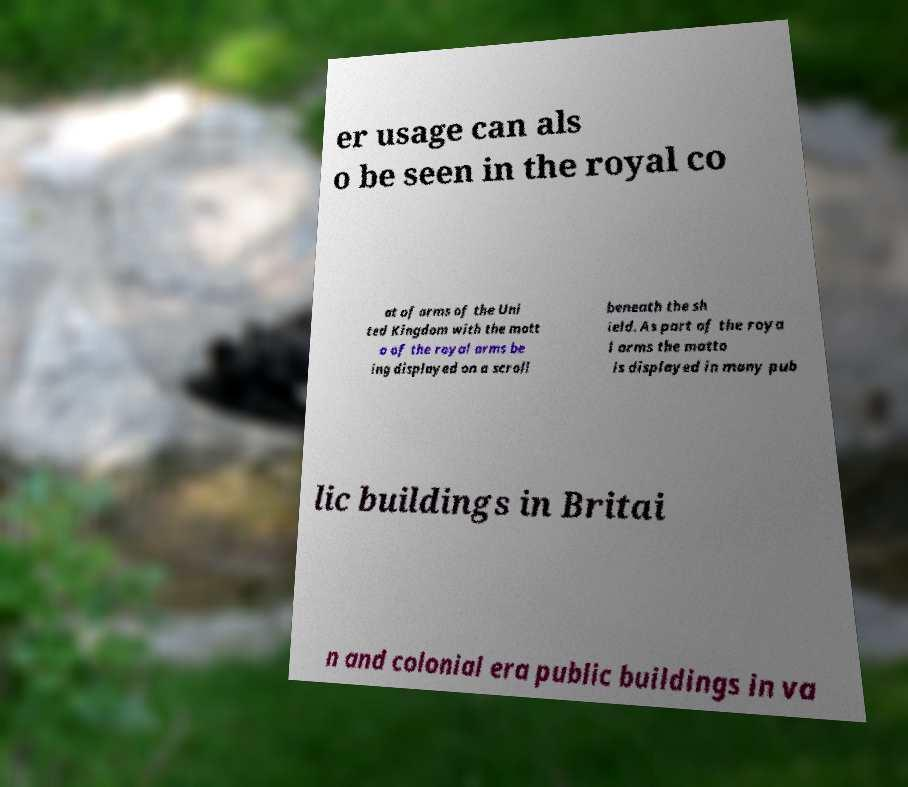What messages or text are displayed in this image? I need them in a readable, typed format. er usage can als o be seen in the royal co at of arms of the Uni ted Kingdom with the mott o of the royal arms be ing displayed on a scroll beneath the sh ield. As part of the roya l arms the motto is displayed in many pub lic buildings in Britai n and colonial era public buildings in va 